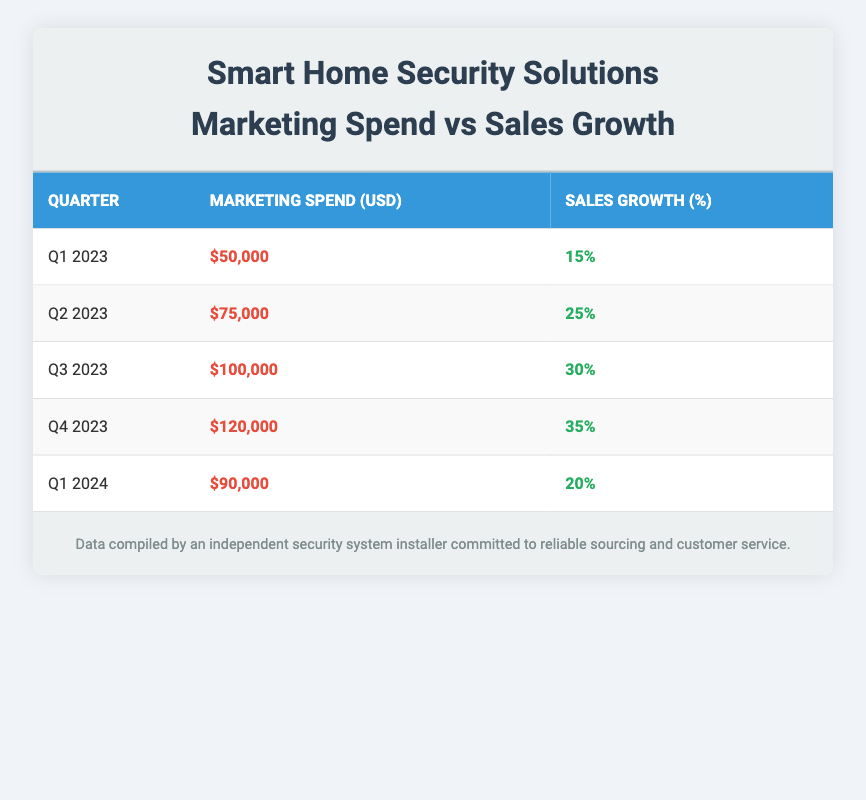What was the marketing spend in Q3 2023? The table shows that in Q3 2023, the marketing spend was listed under the corresponding row, which is $100,000.
Answer: $100,000 What is the sales growth percentage for Q4 2023? By referring to the Q4 2023 row in the table, we can see that the sales growth percentage is noted as 35%.
Answer: 35% What was the increase in marketing spend from Q1 2023 to Q2 2023? The marketing spend in Q1 2023 was $50,000 and in Q2 2023 it was $75,000. To find the increase, we subtract the two: $75,000 - $50,000 = $25,000.
Answer: $25,000 Did the sales growth percentage increase with every subsequent quarter from Q1 2023 to Q4 2023? Observing the sales growth percentages, Q1 2023 shows 15%, Q2 2023 shows 25%, Q3 2023 shows 30%, and Q4 2023 shows 35%. Each quarter displays a growing percentage, confirming that sales growth increased each time.
Answer: Yes What is the average marketing spend for the quarters listed in 2023? First, we sum the marketing spend for Q1 2023, Q2 2023, Q3 2023, and Q4 2023: $50,000 + $75,000 + $100,000 + $120,000 = $345,000. Then we divide by the number of quarters, which is 4: $345,000 / 4 = $86,250.
Answer: $86,250 Was the sales growth in Q1 2024 lower than in Q3 2023? The sales growth for Q1 2024 is 20%, while for Q3 2023 it is 30%. Since 20% is less than 30%, the statement is validated.
Answer: Yes What is the total marketing spend across all quarters from Q1 2023 to Q1 2024? Adding together all marketing spends: $50,000 + $75,000 + $100,000 + $120,000 + $90,000 gives a total of $435,000.
Answer: $435,000 What percentage increase in sales growth does Q4 2023 exhibit compared to Q1 2024? The sales growth in Q4 2023 is 35% and for Q1 2024 it is 20%. To find the percentage decrease, we take the difference (35% - 20% = 15%) and then divide by the original value (20%). This gives us (15% / 20%) * 100 = 75%.
Answer: 75% 